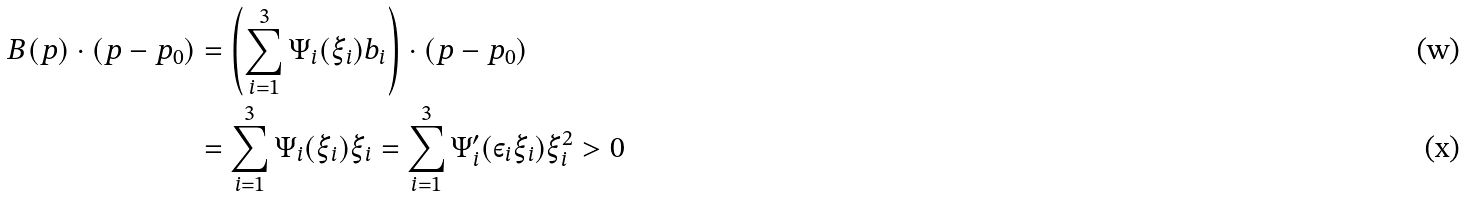Convert formula to latex. <formula><loc_0><loc_0><loc_500><loc_500>B ( p ) \cdot ( p - p _ { 0 } ) & = \left ( \sum _ { i = 1 } ^ { 3 } \Psi _ { i } ( \xi _ { i } ) b _ { i } \right ) \cdot ( p - p _ { 0 } ) \\ & = \sum _ { i = 1 } ^ { 3 } \Psi _ { i } ( \xi _ { i } ) \xi _ { i } = \sum _ { i = 1 } ^ { 3 } \Psi _ { i } ^ { \prime } ( \varepsilon _ { i } \xi _ { i } ) \xi _ { i } ^ { 2 } > 0</formula> 